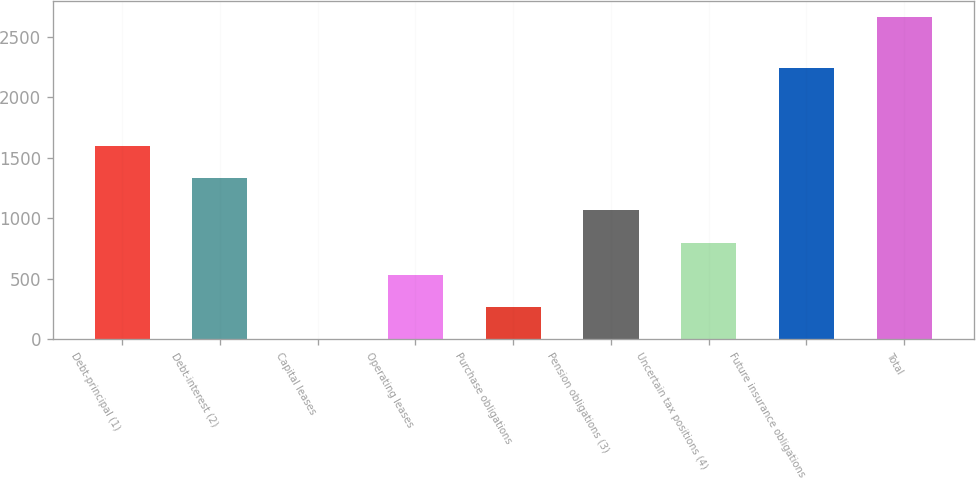Convert chart. <chart><loc_0><loc_0><loc_500><loc_500><bar_chart><fcel>Debt-principal (1)<fcel>Debt-interest (2)<fcel>Capital leases<fcel>Operating leases<fcel>Purchase obligations<fcel>Pension obligations (3)<fcel>Uncertain tax positions (4)<fcel>Future insurance obligations<fcel>Total<nl><fcel>1598.5<fcel>1332.12<fcel>0.22<fcel>532.98<fcel>266.6<fcel>1065.74<fcel>799.36<fcel>2248<fcel>2664<nl></chart> 